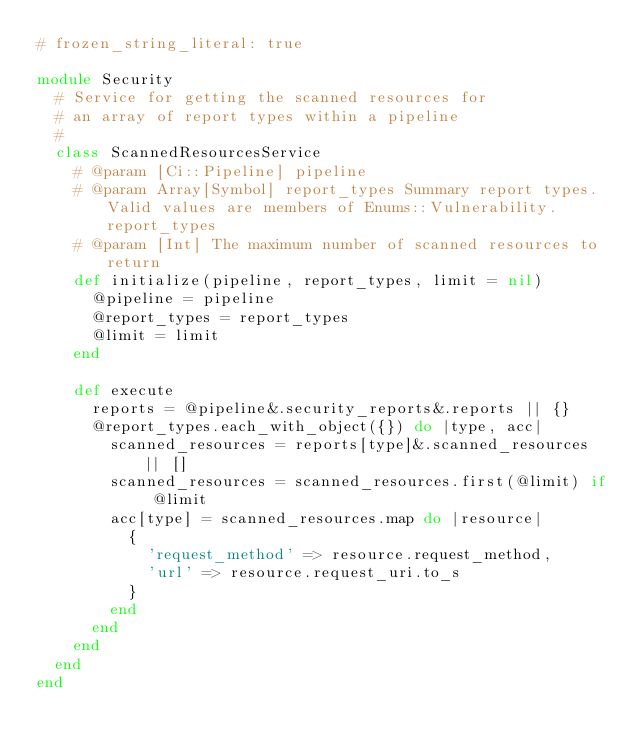Convert code to text. <code><loc_0><loc_0><loc_500><loc_500><_Ruby_># frozen_string_literal: true

module Security
  # Service for getting the scanned resources for
  # an array of report types within a pipeline
  #
  class ScannedResourcesService
    # @param [Ci::Pipeline] pipeline
    # @param Array[Symbol] report_types Summary report types. Valid values are members of Enums::Vulnerability.report_types
    # @param [Int] The maximum number of scanned resources to return
    def initialize(pipeline, report_types, limit = nil)
      @pipeline = pipeline
      @report_types = report_types
      @limit = limit
    end

    def execute
      reports = @pipeline&.security_reports&.reports || {}
      @report_types.each_with_object({}) do |type, acc|
        scanned_resources = reports[type]&.scanned_resources || []
        scanned_resources = scanned_resources.first(@limit) if @limit
        acc[type] = scanned_resources.map do |resource|
          {
            'request_method' => resource.request_method,
            'url' => resource.request_uri.to_s
          }
        end
      end
    end
  end
end
</code> 